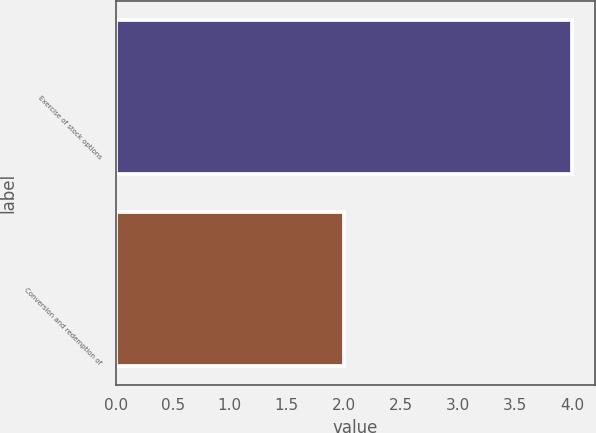Convert chart to OTSL. <chart><loc_0><loc_0><loc_500><loc_500><bar_chart><fcel>Exercise of stock options<fcel>Conversion and redemption of<nl><fcel>4<fcel>2<nl></chart> 